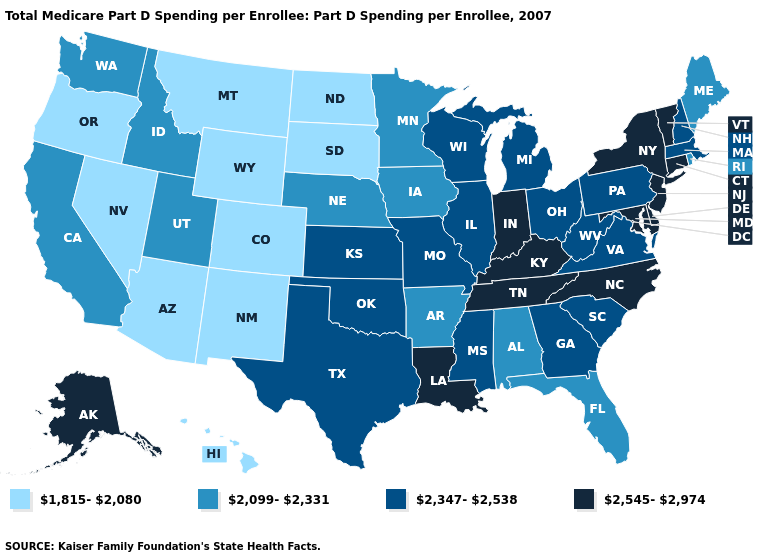Which states hav the highest value in the South?
Give a very brief answer. Delaware, Kentucky, Louisiana, Maryland, North Carolina, Tennessee. Does the map have missing data?
Answer briefly. No. How many symbols are there in the legend?
Give a very brief answer. 4. Name the states that have a value in the range 2,545-2,974?
Give a very brief answer. Alaska, Connecticut, Delaware, Indiana, Kentucky, Louisiana, Maryland, New Jersey, New York, North Carolina, Tennessee, Vermont. Name the states that have a value in the range 1,815-2,080?
Give a very brief answer. Arizona, Colorado, Hawaii, Montana, Nevada, New Mexico, North Dakota, Oregon, South Dakota, Wyoming. Which states hav the highest value in the West?
Answer briefly. Alaska. What is the value of New Mexico?
Answer briefly. 1,815-2,080. Does the map have missing data?
Give a very brief answer. No. Does Louisiana have the lowest value in the USA?
Concise answer only. No. Name the states that have a value in the range 1,815-2,080?
Answer briefly. Arizona, Colorado, Hawaii, Montana, Nevada, New Mexico, North Dakota, Oregon, South Dakota, Wyoming. What is the value of Alabama?
Keep it brief. 2,099-2,331. What is the highest value in states that border Maryland?
Short answer required. 2,545-2,974. Among the states that border Missouri , does Tennessee have the lowest value?
Quick response, please. No. What is the lowest value in states that border Maine?
Short answer required. 2,347-2,538. What is the value of Nebraska?
Give a very brief answer. 2,099-2,331. 